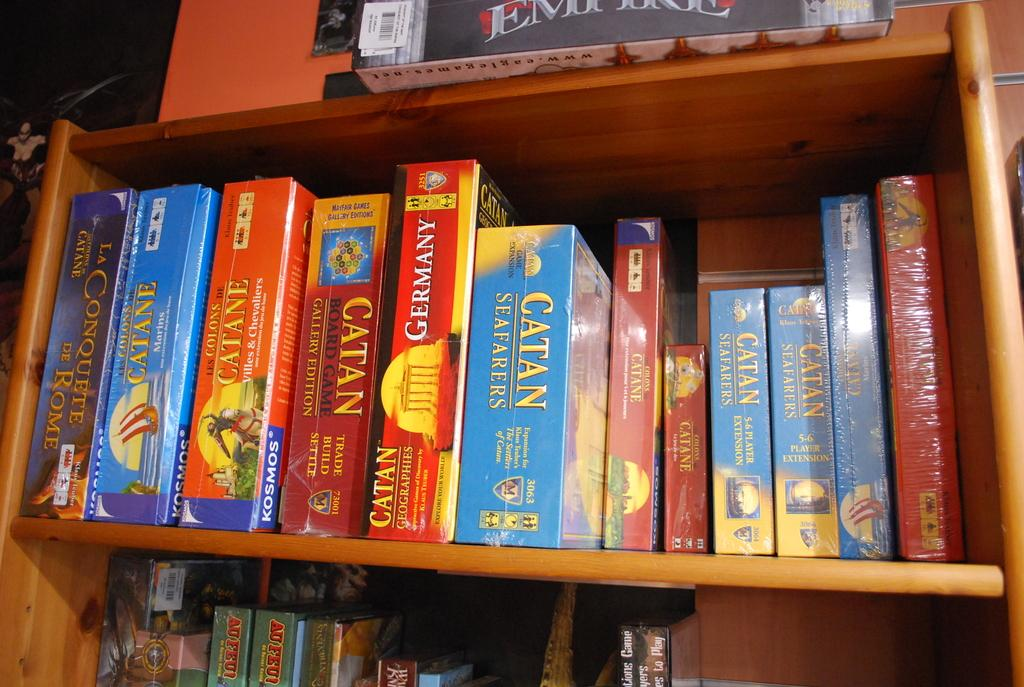<image>
Write a terse but informative summary of the picture. Several versions of the Catan board game sit lined up on a shelf. 